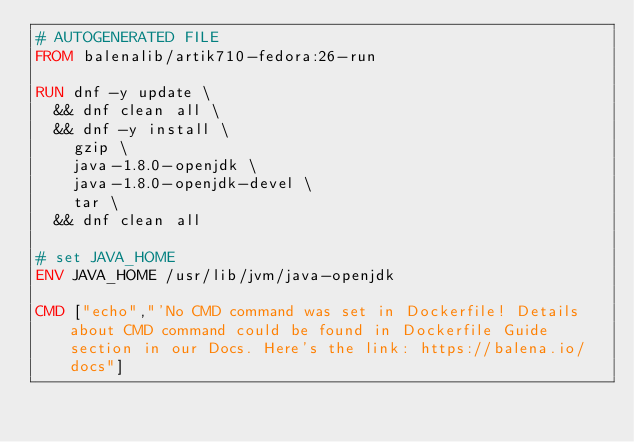<code> <loc_0><loc_0><loc_500><loc_500><_Dockerfile_># AUTOGENERATED FILE
FROM balenalib/artik710-fedora:26-run

RUN dnf -y update \
	&& dnf clean all \
	&& dnf -y install \
		gzip \
		java-1.8.0-openjdk \
		java-1.8.0-openjdk-devel \
		tar \
	&& dnf clean all

# set JAVA_HOME
ENV JAVA_HOME /usr/lib/jvm/java-openjdk

CMD ["echo","'No CMD command was set in Dockerfile! Details about CMD command could be found in Dockerfile Guide section in our Docs. Here's the link: https://balena.io/docs"]</code> 